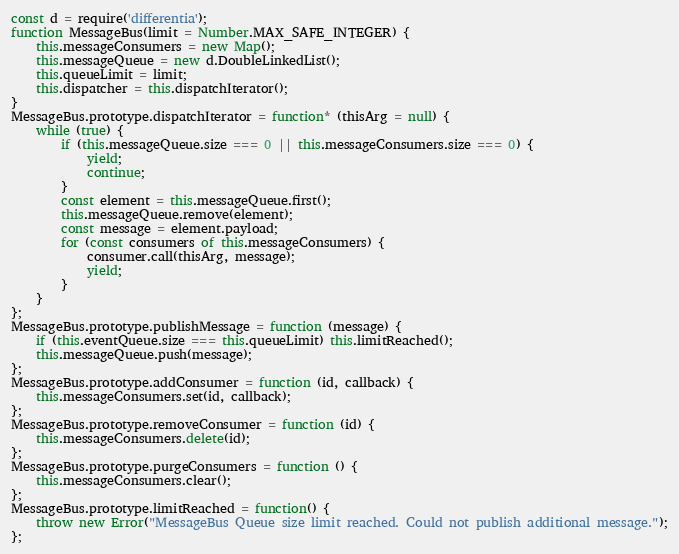<code> <loc_0><loc_0><loc_500><loc_500><_JavaScript_>const d = require('differentia');
function MessageBus(limit = Number.MAX_SAFE_INTEGER) {
	this.messageConsumers = new Map();
	this.messageQueue = new d.DoubleLinkedList();
	this.queueLimit = limit;
	this.dispatcher = this.dispatchIterator();
}
MessageBus.prototype.dispatchIterator = function* (thisArg = null) {
	while (true) {
		if (this.messageQueue.size === 0 || this.messageConsumers.size === 0) {
			yield;
			continue;
		}
		const element = this.messageQueue.first();
		this.messageQueue.remove(element);
		const message = element.payload;
		for (const consumers of this.messageConsumers) {
			consumer.call(thisArg, message);
			yield;
		}
	}
};
MessageBus.prototype.publishMessage = function (message) {
	if (this.eventQueue.size === this.queueLimit) this.limitReached();
	this.messageQueue.push(message);
};
MessageBus.prototype.addConsumer = function (id, callback) {
	this.messageConsumers.set(id, callback);
};
MessageBus.prototype.removeConsumer = function (id) {
	this.messageConsumers.delete(id);
};
MessageBus.prototype.purgeConsumers = function () {
	this.messageConsumers.clear();
};
MessageBus.prototype.limitReached = function() {
	throw new Error("MessageBus Queue size limit reached. Could not publish additional message.");
};</code> 